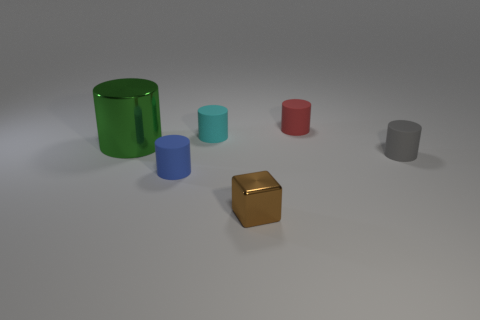What number of yellow things are tiny things or big things?
Your response must be concise. 0. Are there an equal number of tiny metal things that are behind the red rubber cylinder and tiny cyan things behind the cyan object?
Offer a terse response. Yes. There is a shiny thing that is in front of the metal object behind the metallic thing in front of the big cylinder; what color is it?
Make the answer very short. Brown. Is there anything else that has the same color as the metal cylinder?
Give a very brief answer. No. What size is the cylinder on the right side of the red cylinder?
Provide a short and direct response. Small. There is a red rubber object that is the same size as the gray cylinder; what shape is it?
Make the answer very short. Cylinder. Are the tiny thing that is in front of the blue matte cylinder and the tiny cylinder in front of the small gray cylinder made of the same material?
Your answer should be compact. No. The small cylinder in front of the object on the right side of the red cylinder is made of what material?
Your response must be concise. Rubber. There is a metal object to the right of the metal object to the left of the shiny thing in front of the small gray rubber thing; what size is it?
Offer a terse response. Small. Is the blue cylinder the same size as the metal cylinder?
Your answer should be very brief. No. 